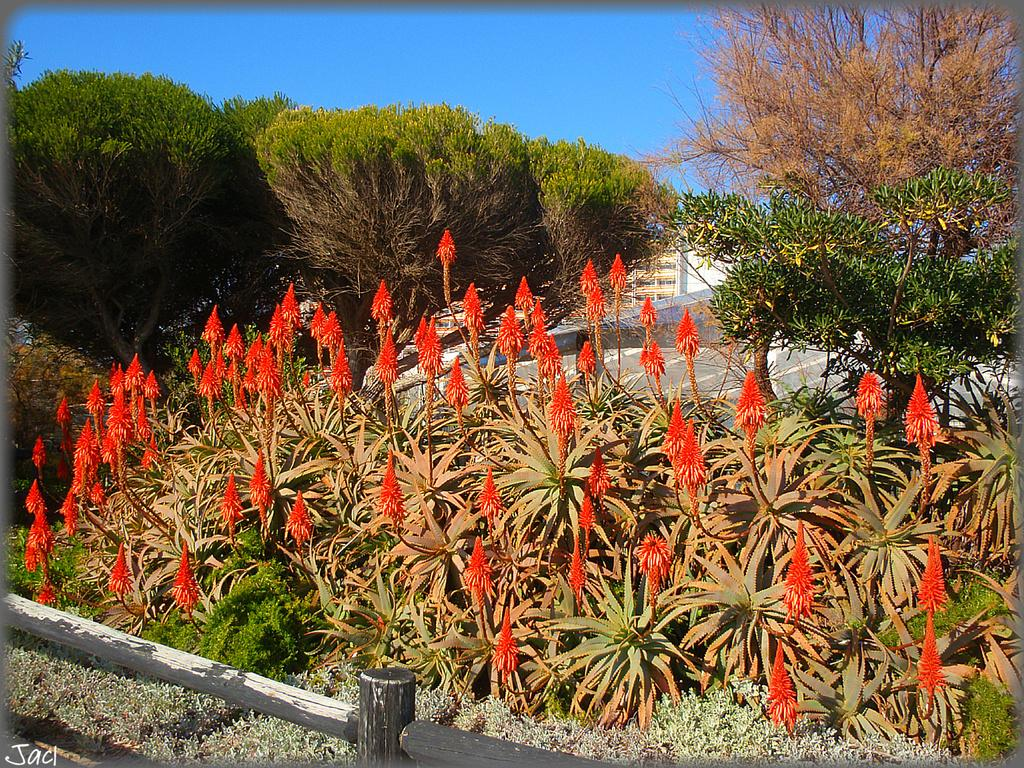What type of vegetation can be seen in the image? There are flowers, plants, and trees in the image. Can you describe the background of the image? There is a building in the background of the image. How many pencils can be seen in the image? There are no pencils present in the image. Can you describe the alley in the image? There is no alley present in the image; it features flowers, plants, trees, and a building in the background. 